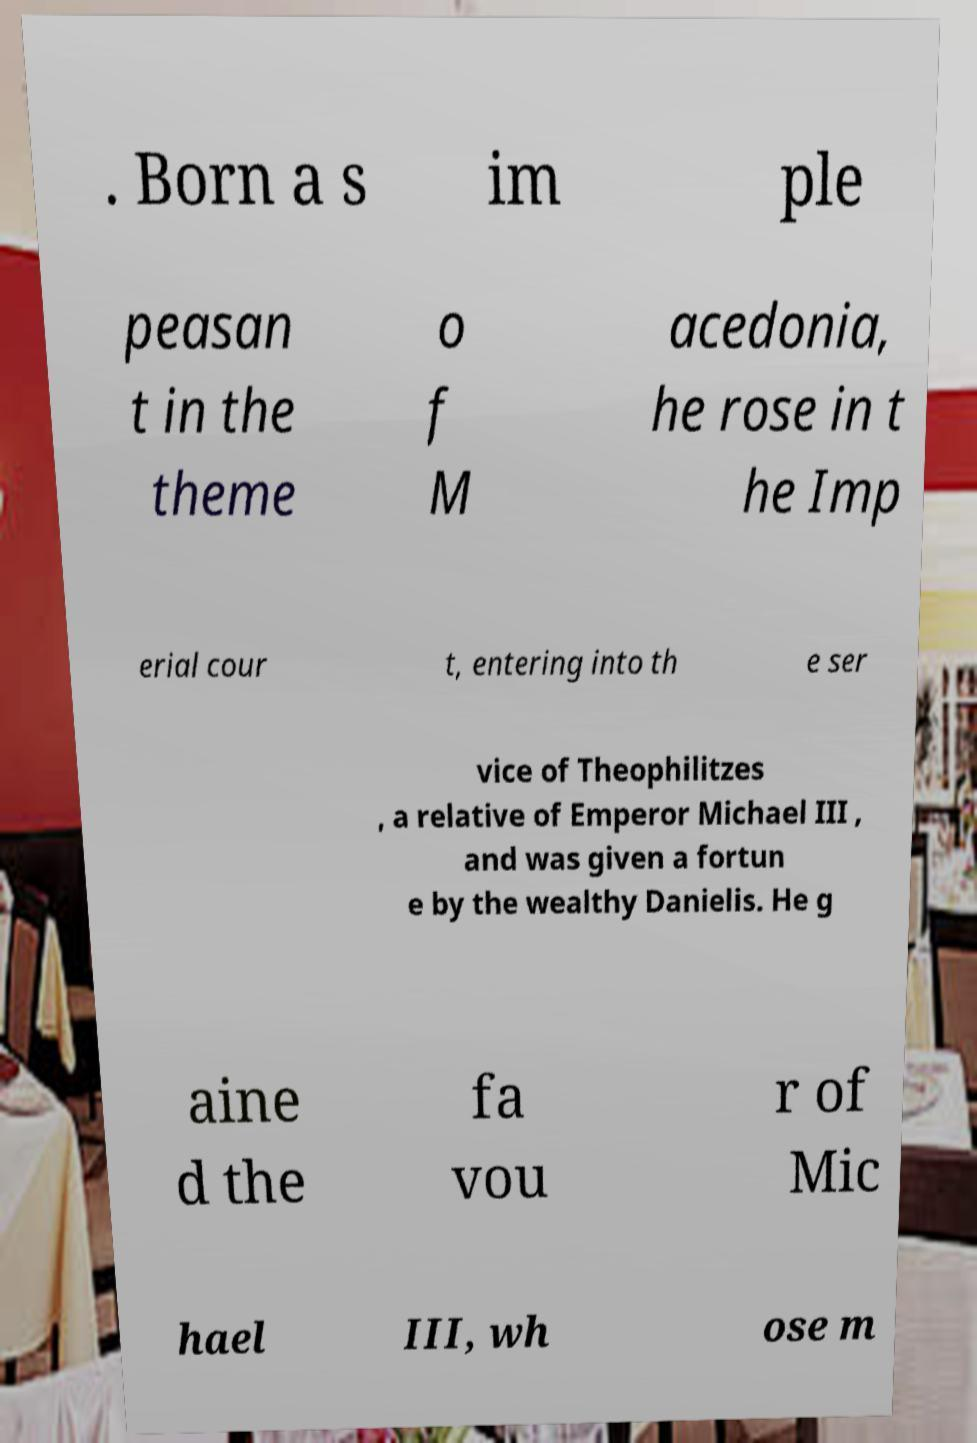Can you accurately transcribe the text from the provided image for me? . Born a s im ple peasan t in the theme o f M acedonia, he rose in t he Imp erial cour t, entering into th e ser vice of Theophilitzes , a relative of Emperor Michael III , and was given a fortun e by the wealthy Danielis. He g aine d the fa vou r of Mic hael III, wh ose m 